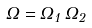Convert formula to latex. <formula><loc_0><loc_0><loc_500><loc_500>\Omega = \Omega _ { 1 } \, \Omega _ { 2 }</formula> 